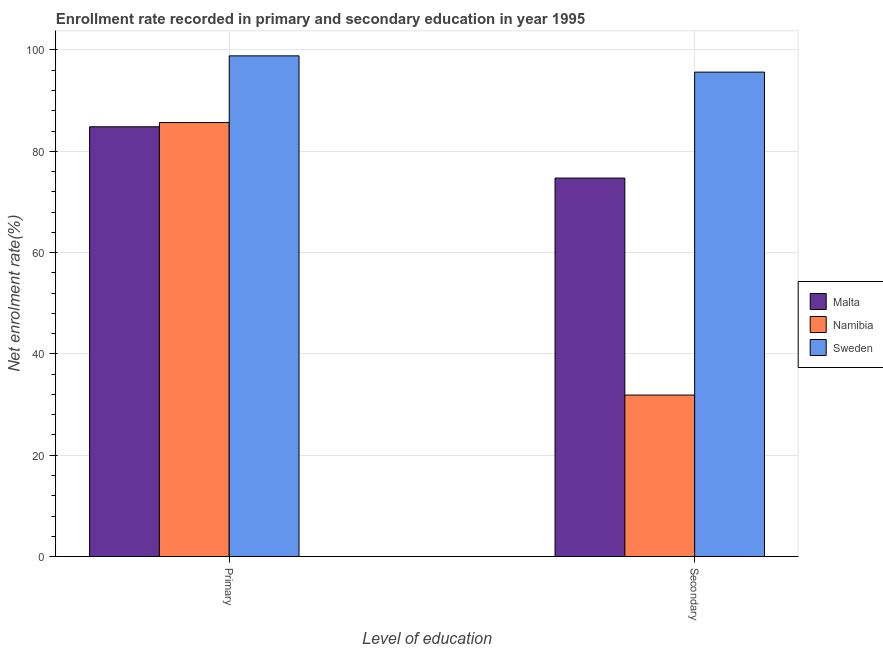How many groups of bars are there?
Offer a terse response. 2. Are the number of bars per tick equal to the number of legend labels?
Offer a very short reply. Yes. What is the label of the 1st group of bars from the left?
Make the answer very short. Primary. What is the enrollment rate in secondary education in Namibia?
Your response must be concise. 31.88. Across all countries, what is the maximum enrollment rate in primary education?
Provide a succinct answer. 98.84. Across all countries, what is the minimum enrollment rate in primary education?
Provide a short and direct response. 84.84. In which country was the enrollment rate in secondary education maximum?
Your answer should be very brief. Sweden. In which country was the enrollment rate in primary education minimum?
Ensure brevity in your answer.  Malta. What is the total enrollment rate in primary education in the graph?
Provide a short and direct response. 269.35. What is the difference between the enrollment rate in primary education in Namibia and that in Malta?
Provide a succinct answer. 0.83. What is the difference between the enrollment rate in secondary education in Namibia and the enrollment rate in primary education in Malta?
Your response must be concise. -52.96. What is the average enrollment rate in primary education per country?
Give a very brief answer. 89.78. What is the difference between the enrollment rate in secondary education and enrollment rate in primary education in Malta?
Make the answer very short. -10.13. In how many countries, is the enrollment rate in secondary education greater than 64 %?
Keep it short and to the point. 2. What is the ratio of the enrollment rate in secondary education in Sweden to that in Namibia?
Provide a short and direct response. 3. Is the enrollment rate in primary education in Namibia less than that in Malta?
Give a very brief answer. No. In how many countries, is the enrollment rate in secondary education greater than the average enrollment rate in secondary education taken over all countries?
Your answer should be compact. 2. What does the 2nd bar from the left in Primary represents?
Offer a very short reply. Namibia. What does the 2nd bar from the right in Secondary represents?
Provide a short and direct response. Namibia. How many countries are there in the graph?
Your answer should be compact. 3. Are the values on the major ticks of Y-axis written in scientific E-notation?
Offer a very short reply. No. Does the graph contain grids?
Ensure brevity in your answer.  Yes. How many legend labels are there?
Your answer should be compact. 3. What is the title of the graph?
Provide a short and direct response. Enrollment rate recorded in primary and secondary education in year 1995. What is the label or title of the X-axis?
Keep it short and to the point. Level of education. What is the label or title of the Y-axis?
Offer a very short reply. Net enrolment rate(%). What is the Net enrolment rate(%) in Malta in Primary?
Give a very brief answer. 84.84. What is the Net enrolment rate(%) in Namibia in Primary?
Offer a terse response. 85.67. What is the Net enrolment rate(%) in Sweden in Primary?
Offer a terse response. 98.84. What is the Net enrolment rate(%) in Malta in Secondary?
Your answer should be very brief. 74.71. What is the Net enrolment rate(%) of Namibia in Secondary?
Your answer should be compact. 31.88. What is the Net enrolment rate(%) of Sweden in Secondary?
Your answer should be compact. 95.63. Across all Level of education, what is the maximum Net enrolment rate(%) of Malta?
Offer a very short reply. 84.84. Across all Level of education, what is the maximum Net enrolment rate(%) of Namibia?
Offer a terse response. 85.67. Across all Level of education, what is the maximum Net enrolment rate(%) of Sweden?
Keep it short and to the point. 98.84. Across all Level of education, what is the minimum Net enrolment rate(%) in Malta?
Provide a short and direct response. 74.71. Across all Level of education, what is the minimum Net enrolment rate(%) of Namibia?
Offer a very short reply. 31.88. Across all Level of education, what is the minimum Net enrolment rate(%) in Sweden?
Keep it short and to the point. 95.63. What is the total Net enrolment rate(%) of Malta in the graph?
Your response must be concise. 159.55. What is the total Net enrolment rate(%) of Namibia in the graph?
Give a very brief answer. 117.55. What is the total Net enrolment rate(%) of Sweden in the graph?
Offer a terse response. 194.47. What is the difference between the Net enrolment rate(%) in Malta in Primary and that in Secondary?
Provide a short and direct response. 10.13. What is the difference between the Net enrolment rate(%) of Namibia in Primary and that in Secondary?
Keep it short and to the point. 53.8. What is the difference between the Net enrolment rate(%) of Sweden in Primary and that in Secondary?
Provide a succinct answer. 3.21. What is the difference between the Net enrolment rate(%) of Malta in Primary and the Net enrolment rate(%) of Namibia in Secondary?
Ensure brevity in your answer.  52.96. What is the difference between the Net enrolment rate(%) in Malta in Primary and the Net enrolment rate(%) in Sweden in Secondary?
Your response must be concise. -10.79. What is the difference between the Net enrolment rate(%) in Namibia in Primary and the Net enrolment rate(%) in Sweden in Secondary?
Provide a succinct answer. -9.96. What is the average Net enrolment rate(%) in Malta per Level of education?
Provide a short and direct response. 79.78. What is the average Net enrolment rate(%) in Namibia per Level of education?
Offer a terse response. 58.77. What is the average Net enrolment rate(%) in Sweden per Level of education?
Provide a short and direct response. 97.24. What is the difference between the Net enrolment rate(%) of Malta and Net enrolment rate(%) of Namibia in Primary?
Keep it short and to the point. -0.83. What is the difference between the Net enrolment rate(%) in Malta and Net enrolment rate(%) in Sweden in Primary?
Offer a terse response. -14. What is the difference between the Net enrolment rate(%) in Namibia and Net enrolment rate(%) in Sweden in Primary?
Offer a terse response. -13.17. What is the difference between the Net enrolment rate(%) of Malta and Net enrolment rate(%) of Namibia in Secondary?
Offer a very short reply. 42.84. What is the difference between the Net enrolment rate(%) of Malta and Net enrolment rate(%) of Sweden in Secondary?
Your answer should be compact. -20.92. What is the difference between the Net enrolment rate(%) in Namibia and Net enrolment rate(%) in Sweden in Secondary?
Your response must be concise. -63.75. What is the ratio of the Net enrolment rate(%) in Malta in Primary to that in Secondary?
Provide a short and direct response. 1.14. What is the ratio of the Net enrolment rate(%) of Namibia in Primary to that in Secondary?
Your response must be concise. 2.69. What is the ratio of the Net enrolment rate(%) in Sweden in Primary to that in Secondary?
Your answer should be compact. 1.03. What is the difference between the highest and the second highest Net enrolment rate(%) in Malta?
Make the answer very short. 10.13. What is the difference between the highest and the second highest Net enrolment rate(%) of Namibia?
Your answer should be compact. 53.8. What is the difference between the highest and the second highest Net enrolment rate(%) of Sweden?
Your response must be concise. 3.21. What is the difference between the highest and the lowest Net enrolment rate(%) of Malta?
Offer a very short reply. 10.13. What is the difference between the highest and the lowest Net enrolment rate(%) of Namibia?
Give a very brief answer. 53.8. What is the difference between the highest and the lowest Net enrolment rate(%) in Sweden?
Your answer should be very brief. 3.21. 